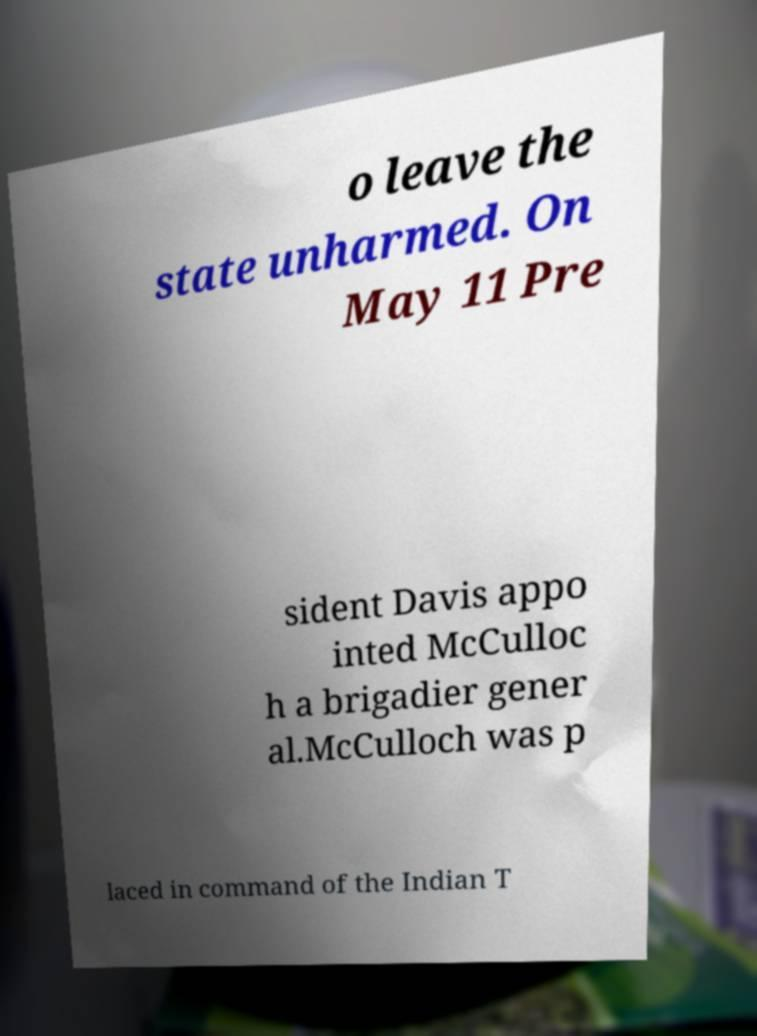Could you assist in decoding the text presented in this image and type it out clearly? o leave the state unharmed. On May 11 Pre sident Davis appo inted McCulloc h a brigadier gener al.McCulloch was p laced in command of the Indian T 